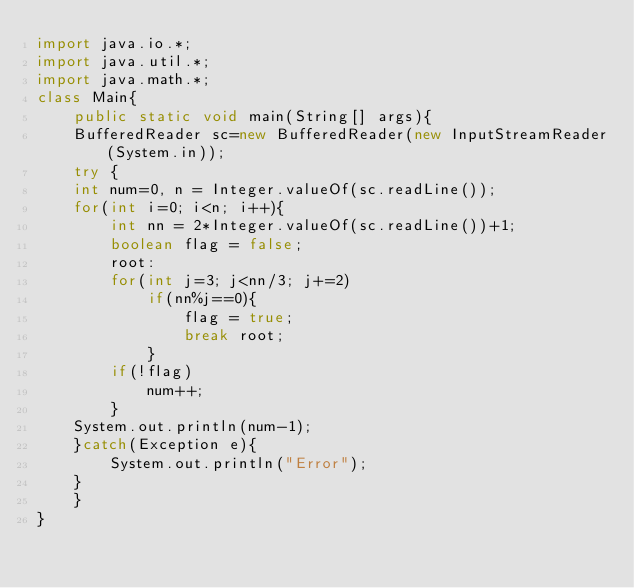Convert code to text. <code><loc_0><loc_0><loc_500><loc_500><_Java_>import java.io.*;
import java.util.*;
import java.math.*;
class Main{
    public static void main(String[] args){
    BufferedReader sc=new BufferedReader(new InputStreamReader(System.in));
    try {
	int num=0, n = Integer.valueOf(sc.readLine());
	for(int i=0; i<n; i++){
		int nn = 2*Integer.valueOf(sc.readLine())+1;
		boolean flag = false;
		root:
		for(int j=3; j<nn/3; j+=2)
			if(nn%j==0){
				flag = true;
				break root;
			}
		if(!flag)
			num++;
		}
	System.out.println(num-1);
    }catch(Exception e){
        System.out.println("Error");
    }
    }
}</code> 